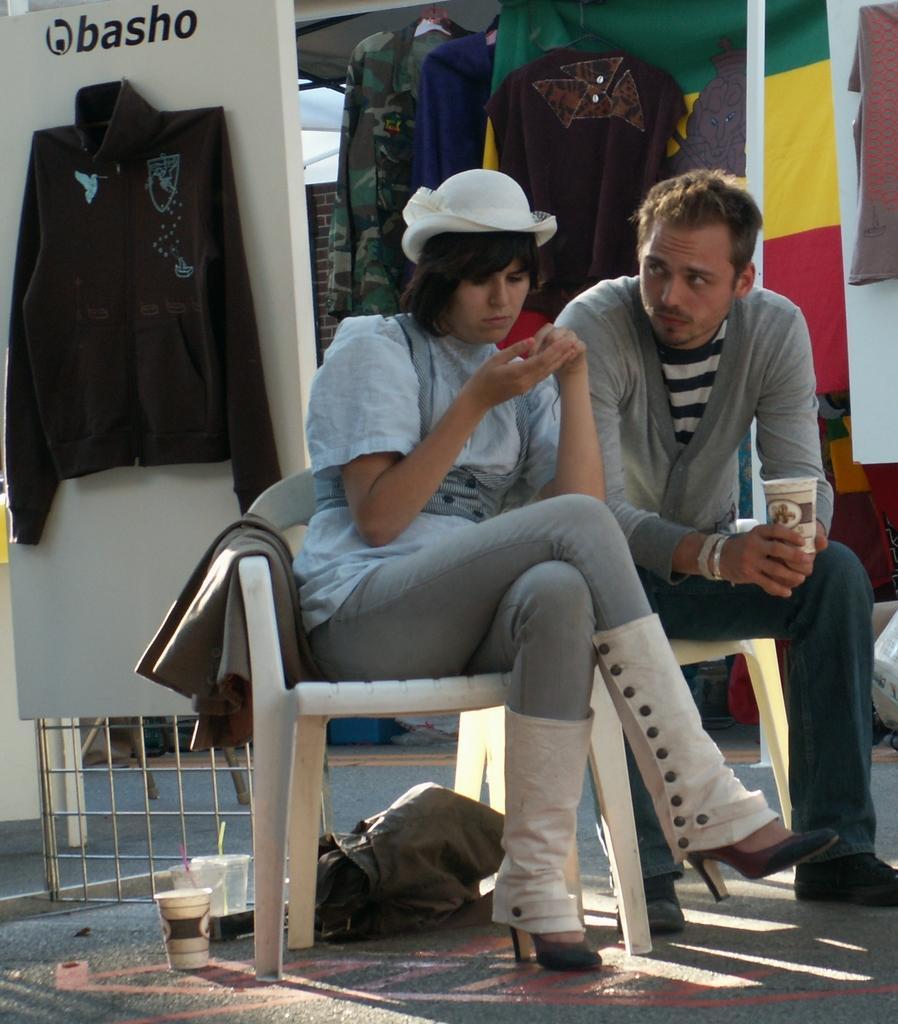How would you summarize this image in a sentence or two? Here we see two people Seated on the chair a man and a woman and we see few clothes hanging at their back. 